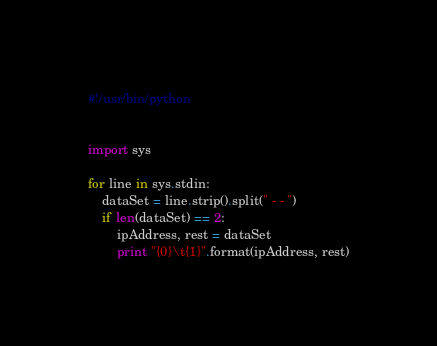<code> <loc_0><loc_0><loc_500><loc_500><_Python_>#!/usr/bin/python


import sys

for line in sys.stdin:
	dataSet = line.strip().split(" - - ")
	if len(dataSet) == 2:
		ipAddress, rest = dataSet
		print "{0}\t{1}".format(ipAddress, rest)
</code> 